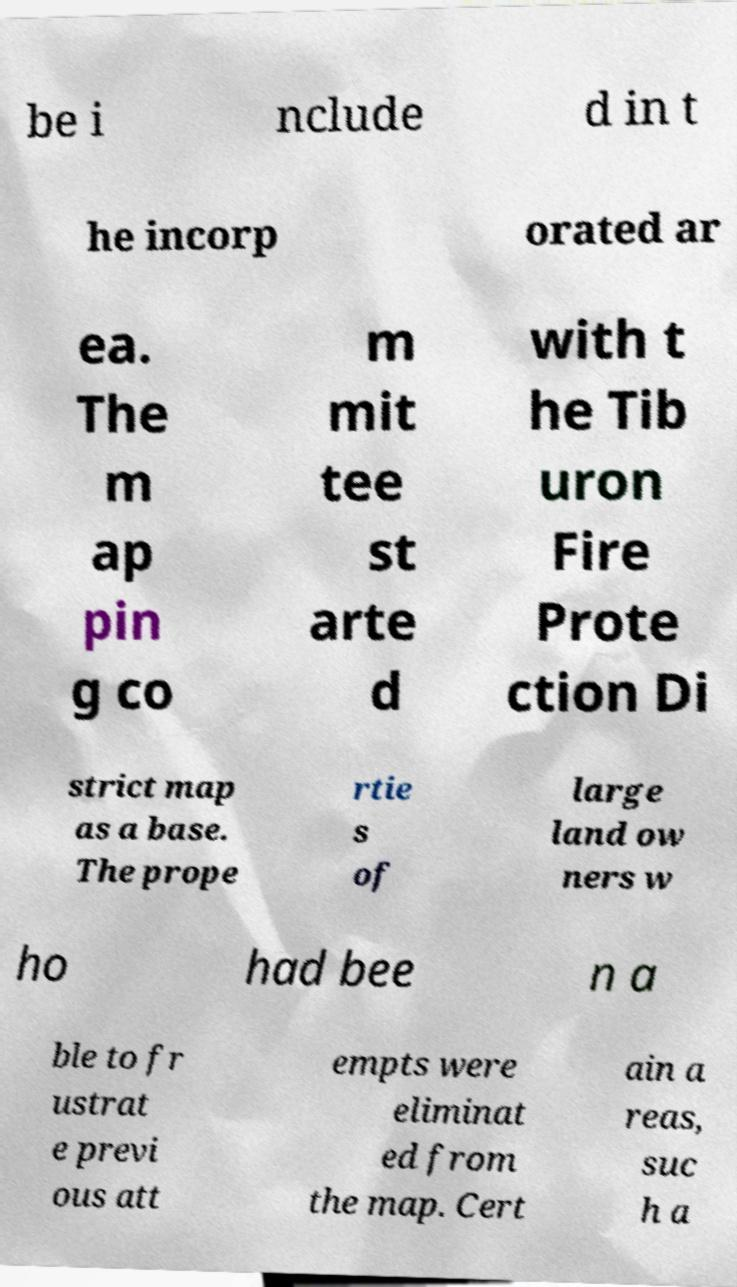What messages or text are displayed in this image? I need them in a readable, typed format. be i nclude d in t he incorp orated ar ea. The m ap pin g co m mit tee st arte d with t he Tib uron Fire Prote ction Di strict map as a base. The prope rtie s of large land ow ners w ho had bee n a ble to fr ustrat e previ ous att empts were eliminat ed from the map. Cert ain a reas, suc h a 